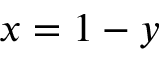<formula> <loc_0><loc_0><loc_500><loc_500>x = 1 - y</formula> 